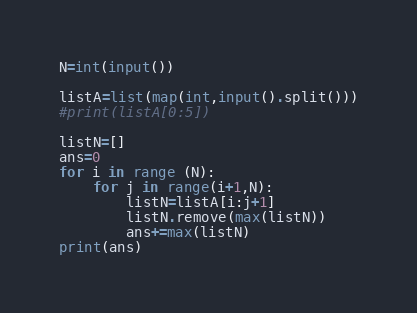Convert code to text. <code><loc_0><loc_0><loc_500><loc_500><_Python_>N=int(input())

listA=list(map(int,input().split()))
#print(listA[0:5])

listN=[]
ans=0
for i in range (N):
	for j in range(i+1,N):
		listN=listA[i:j+1]
		listN.remove(max(listN))
		ans+=max(listN)
print(ans)</code> 